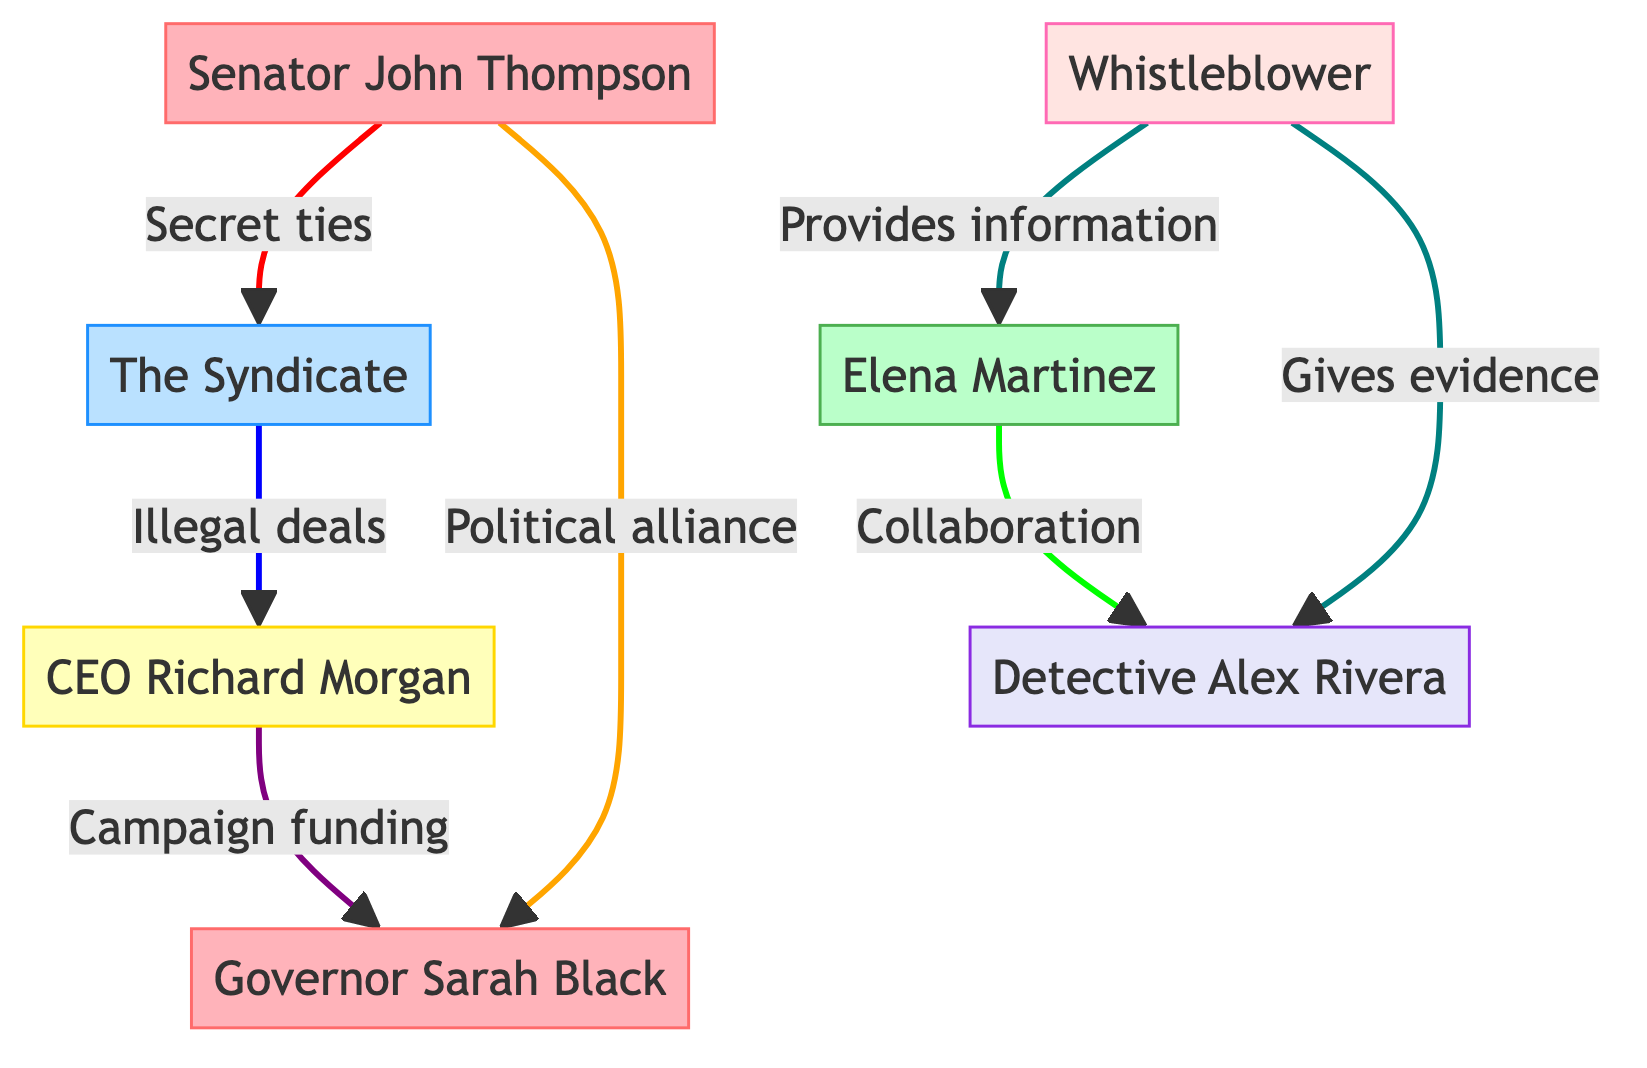What is the role of Elena Martinez? The role of each node is indicated, and Elena Martinez is classified as a Journalist, which is confirmed in her description.
Answer: Journalist How many nodes are in the diagram? The diagram includes a list of nodes, and counting them reveals that there are a total of seven distinct nodes.
Answer: 7 What relationship exists between Senator John Thompson and The Syndicate? The link between Senator John Thompson and The Syndicate is labeled as "Secret ties," which indicates a connection of mutual benefit.
Answer: Secret ties Who provides evidence to Detective Alex Rivera? The diagram shows a link from the Whistleblower to Detective Alex Rivera labeled "Gives evidence," which identifies the source of evidence as the Whistleblower.
Answer: Whistleblower How many associations involve Governor Sarah Black? Reviewing the links related to Governor Sarah Black shows two connections: one with Senator John Thompson (Political alliance) and one with CEO Richard Morgan (Campaign funding), resulting in a total of two associations.
Answer: 2 What is the main connection between The Syndicate and CEO Richard Morgan? The relationship between The Syndicate and CEO Richard Morgan is indicated by the label "Illegal deals," which describes the nature of their connection.
Answer: Illegal deals Which node collaborates with Elena Martinez to uncover corruption? According to the diagram, Detective Alex Rivera collaborates with Elena Martinez to uncover corruption, as indicated by the link labeled "Collaboration."
Answer: Detective Alex Rivera What type of evidence does the Whistleblower provide to Detective Alex Rivera? The label of the link indicates that the Whistleblower gives evidence to Detective Alex Rivera, specifying the nature of the information shared.
Answer: Evidence What is the relationship between Senator John Thompson and Governor Sarah Black? The diagram shows a "Political alliance" linking Senator John Thompson and Governor Sarah Black, defining their association in terms of political collaboration.
Answer: Political alliance 